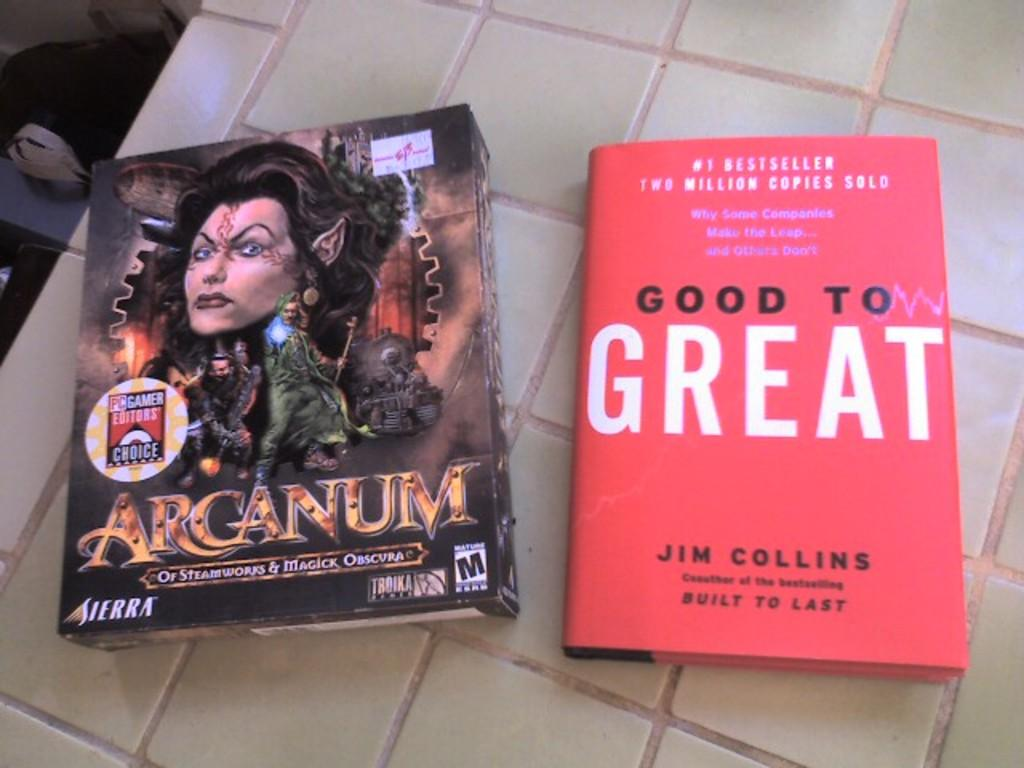Provide a one-sentence caption for the provided image. A book with a red cover was written by Jim Collins. 